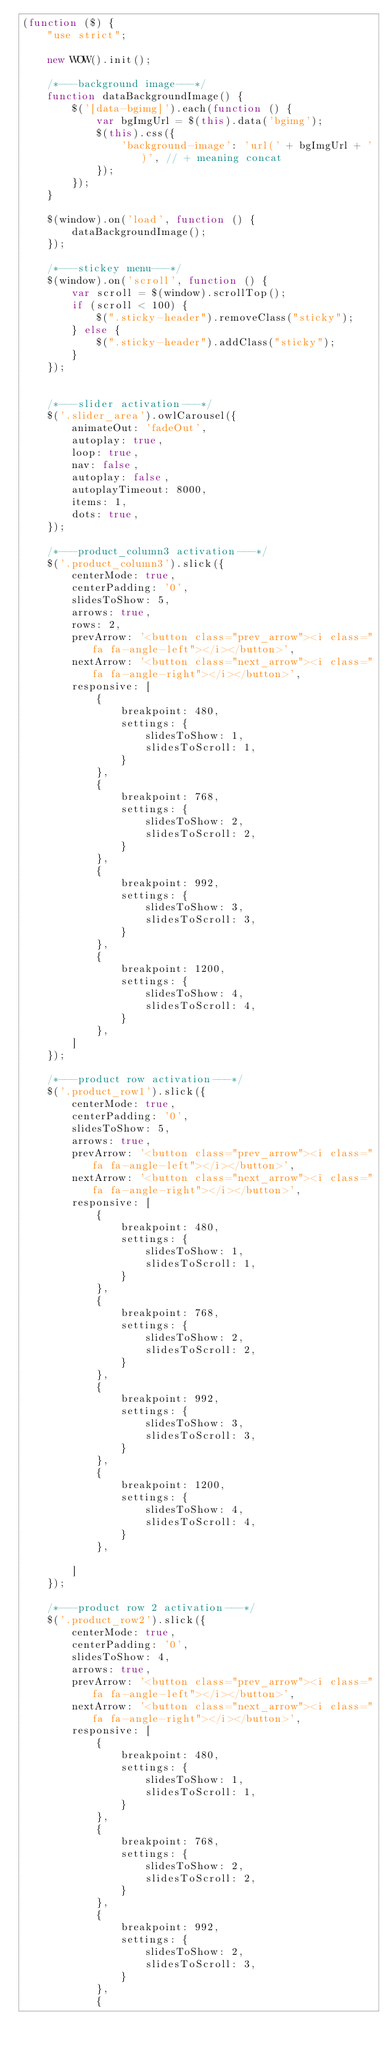Convert code to text. <code><loc_0><loc_0><loc_500><loc_500><_JavaScript_>(function ($) {
	"use strict";

	new WOW().init();

	/*---background image---*/
	function dataBackgroundImage() {
		$('[data-bgimg]').each(function () {
			var bgImgUrl = $(this).data('bgimg');
			$(this).css({
				'background-image': 'url(' + bgImgUrl + ')', // + meaning concat
			});
		});
	}

	$(window).on('load', function () {
		dataBackgroundImage();
	});

	/*---stickey menu---*/
	$(window).on('scroll', function () {
		var scroll = $(window).scrollTop();
		if (scroll < 100) {
			$(".sticky-header").removeClass("sticky");
		} else {
			$(".sticky-header").addClass("sticky");
		}
	});


	/*---slider activation---*/
	$('.slider_area').owlCarousel({
		animateOut: 'fadeOut',
		autoplay: true,
		loop: true,
		nav: false,
		autoplay: false,
		autoplayTimeout: 8000,
		items: 1,
		dots: true,
	});

	/*---product_column3 activation---*/
	$('.product_column3').slick({
		centerMode: true,
		centerPadding: '0',
		slidesToShow: 5,
		arrows: true,
		rows: 2,
		prevArrow: '<button class="prev_arrow"><i class="fa fa-angle-left"></i></button>',
		nextArrow: '<button class="next_arrow"><i class="fa fa-angle-right"></i></button>',
		responsive: [
			{
				breakpoint: 480,
				settings: {
					slidesToShow: 1,
					slidesToScroll: 1,
				}
			},
			{
				breakpoint: 768,
				settings: {
					slidesToShow: 2,
					slidesToScroll: 2,
				}
			},
			{
				breakpoint: 992,
				settings: {
					slidesToShow: 3,
					slidesToScroll: 3,
				}
			},
			{
				breakpoint: 1200,
				settings: {
					slidesToShow: 4,
					slidesToScroll: 4,
				}
			},
		]
	});

	/*---product row activation---*/
	$('.product_row1').slick({
		centerMode: true,
		centerPadding: '0',
		slidesToShow: 5,
		arrows: true,
		prevArrow: '<button class="prev_arrow"><i class="fa fa-angle-left"></i></button>',
		nextArrow: '<button class="next_arrow"><i class="fa fa-angle-right"></i></button>',
		responsive: [
			{
				breakpoint: 480,
				settings: {
					slidesToShow: 1,
					slidesToScroll: 1,
				}
			},
			{
				breakpoint: 768,
				settings: {
					slidesToShow: 2,
					slidesToScroll: 2,
				}
			},
			{
				breakpoint: 992,
				settings: {
					slidesToShow: 3,
					slidesToScroll: 3,
				}
			},
			{
				breakpoint: 1200,
				settings: {
					slidesToShow: 4,
					slidesToScroll: 4,
				}
			},

		]
	});

	/*---product row 2 activation---*/
	$('.product_row2').slick({
		centerMode: true,
		centerPadding: '0',
		slidesToShow: 4,
		arrows: true,
		prevArrow: '<button class="prev_arrow"><i class="fa fa-angle-left"></i></button>',
		nextArrow: '<button class="next_arrow"><i class="fa fa-angle-right"></i></button>',
		responsive: [
			{
				breakpoint: 480,
				settings: {
					slidesToShow: 1,
					slidesToScroll: 1,
				}
			},
			{
				breakpoint: 768,
				settings: {
					slidesToShow: 2,
					slidesToScroll: 2,
				}
			},
			{
				breakpoint: 992,
				settings: {
					slidesToShow: 2,
					slidesToScroll: 3,
				}
			},
			{</code> 